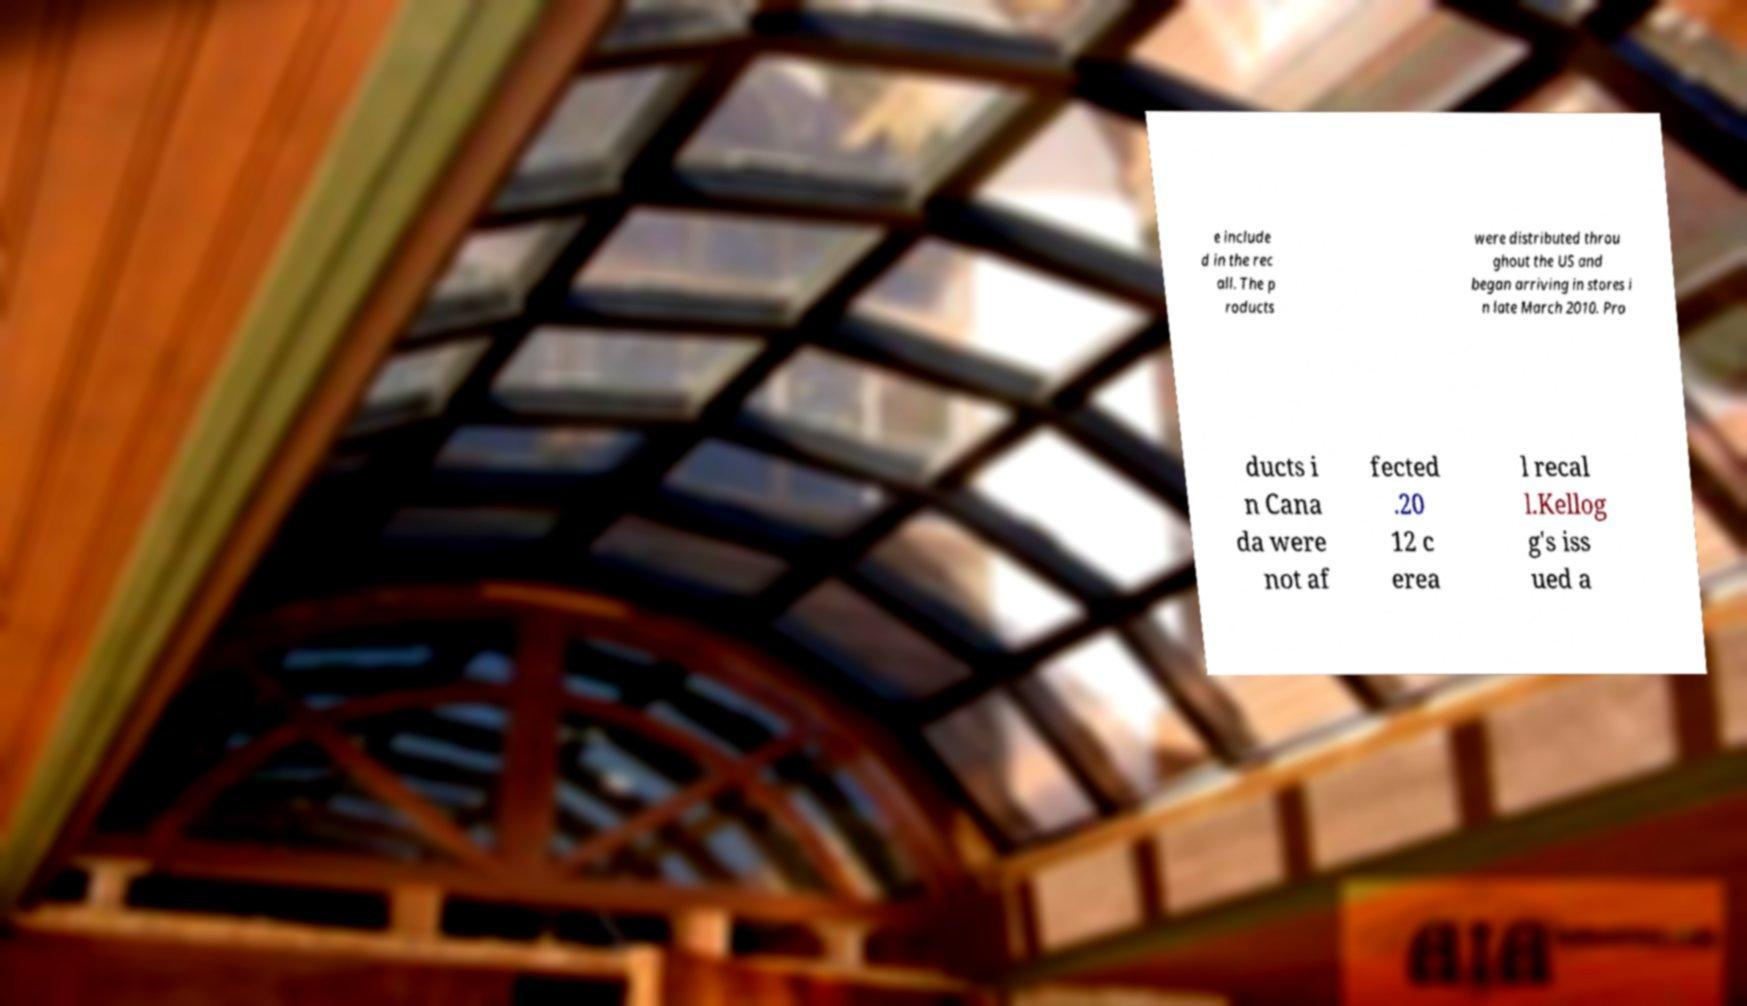Can you accurately transcribe the text from the provided image for me? e include d in the rec all. The p roducts were distributed throu ghout the US and began arriving in stores i n late March 2010. Pro ducts i n Cana da were not af fected .20 12 c erea l recal l.Kellog g's iss ued a 